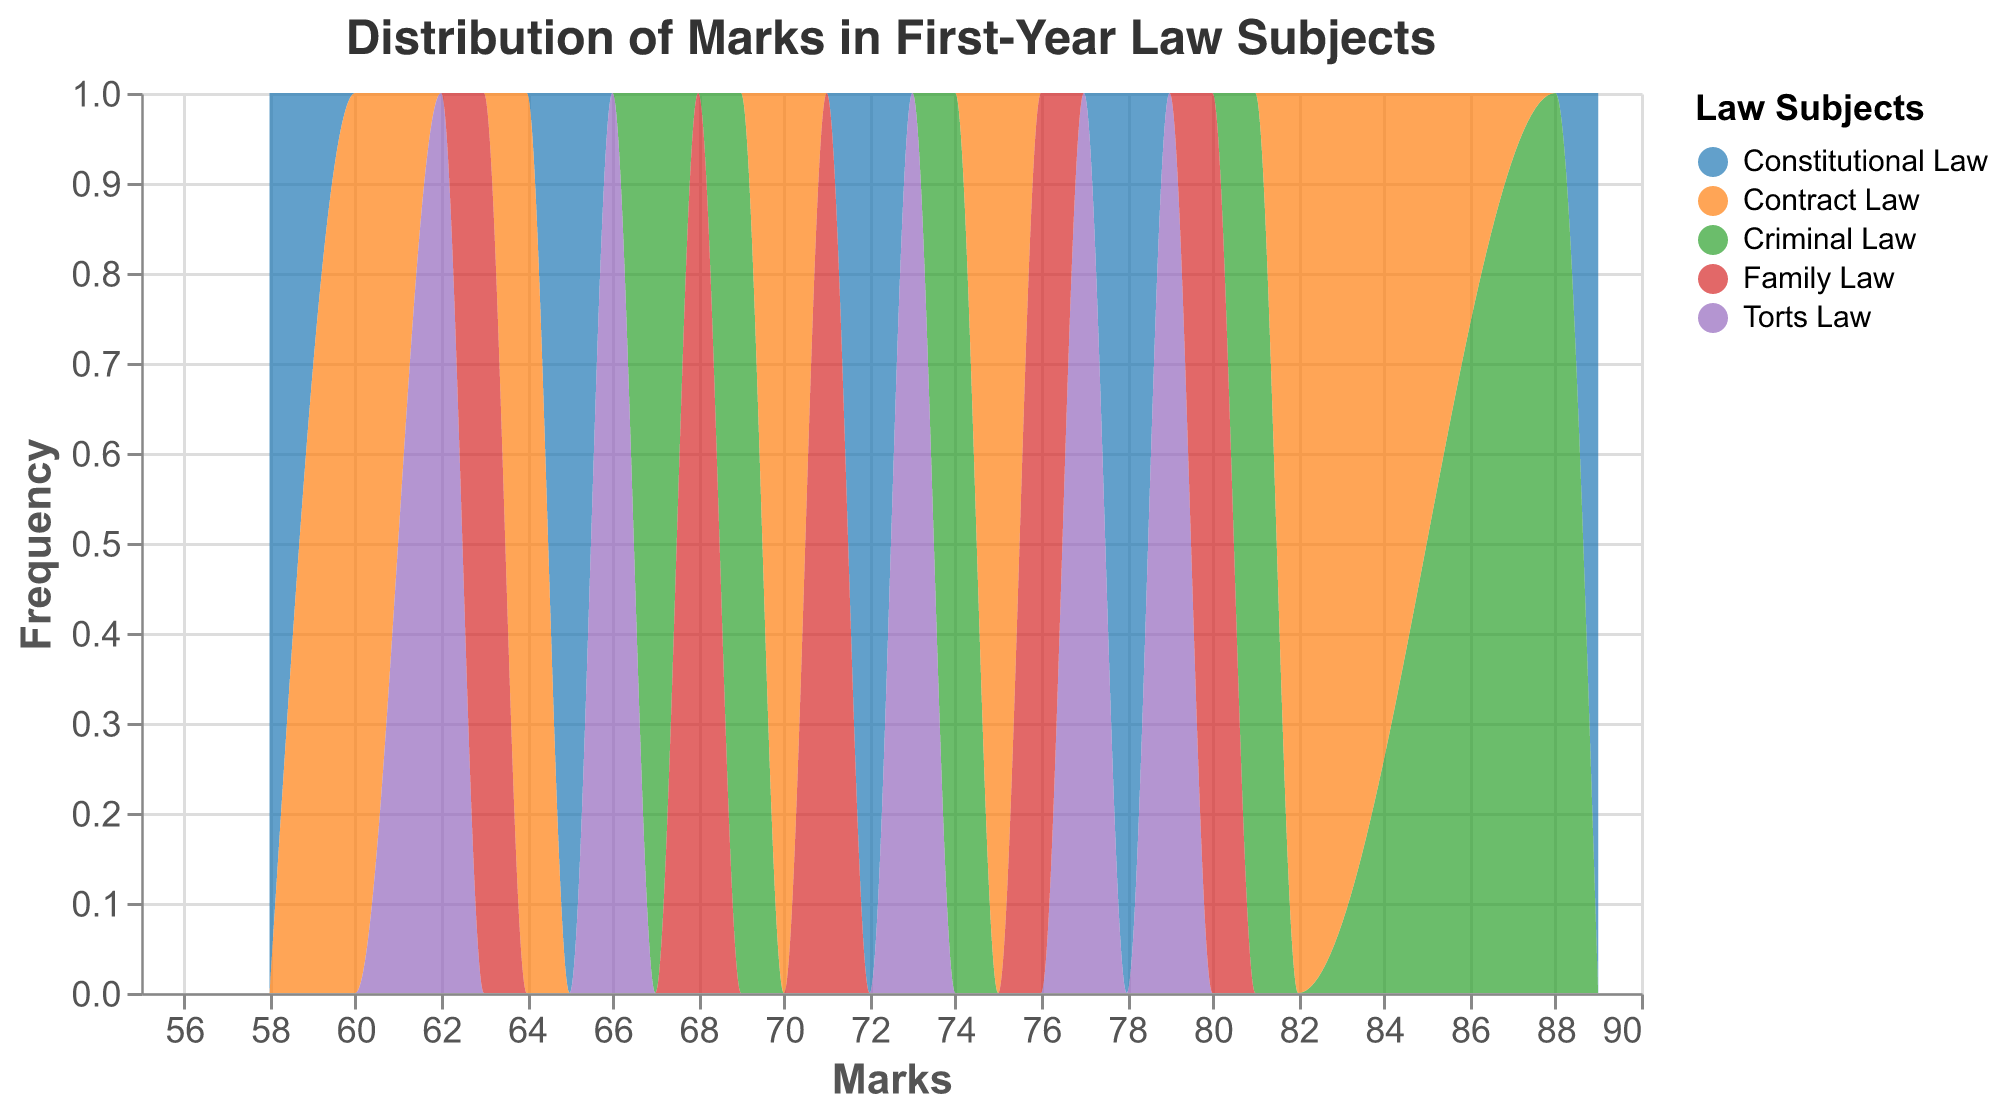What is the title of the plot? The title is located at the top of the plot. It summarizes the main theme or subject of the plot.
Answer: Distribution of Marks in First-Year Law Subjects Which subject has the highest mark recorded? Look for the highest value on the x-axis and check the corresponding color-coded area on the plot to identify the subject.
Answer: Constitutional Law Which subject features marks in the range of 60 to 70? Observe the x-axis for the range 60 to 70 and find the colors representing different subjects within that range.
Answer: Contract Law, Torts Law, and Family Law What is the most frequently occurring mark for Criminal Law? Find the peak of the area corresponding to Criminal Law and note the value on the x-axis.
Answer: 81 How many marks were recorded for Constitutional Law? Count the number of data points for Constitutional Law, which is shown by the frequency of marks in the plot.
Answer: 5 Compare the average marks of Constitutional Law and Torts Law. Which has a higher average? Calculate the average mark for each subject by summing their marks and dividing by the number of data points. For Constitutional Law: (78 + 65 + 89 + 58 + 72) / 5 = 72.4; For Torts Law: (62 + 79 + 66 + 73 + 77) / 5 = 71.4
Answer: Constitutional Law Which subject has the most uniform distribution of marks? Assess the distribution shapes on the plot to see which one has a more even spread of marks.
Answer: Family Law What is the range of marks for Contract Law? Identify the lowest and highest marks for Contract Law and calculate the difference.
Answer: 60 to 82 Is there any subject where the marks are clustered around a narrow range? Look for areas on the plot where marks for a subject are close together instead of being spread out.
Answer: Criminal Law Between Family Law and Criminal Law, which has the broader range of marks? Compare the ranges by noting the lowest and highest marks of each subject. For Family Law: 63 to 80; For Criminal Law: 67 to 88.
Answer: Criminal Law 